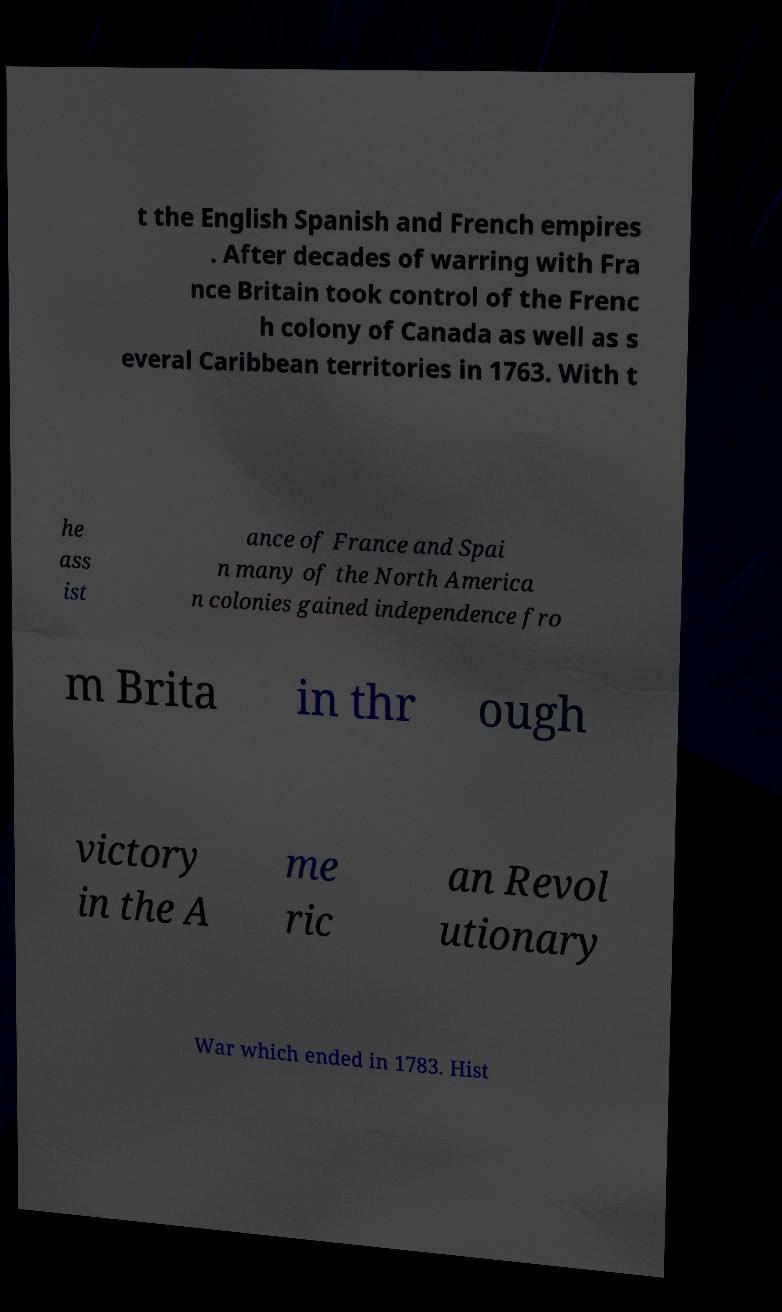For documentation purposes, I need the text within this image transcribed. Could you provide that? t the English Spanish and French empires . After decades of warring with Fra nce Britain took control of the Frenc h colony of Canada as well as s everal Caribbean territories in 1763. With t he ass ist ance of France and Spai n many of the North America n colonies gained independence fro m Brita in thr ough victory in the A me ric an Revol utionary War which ended in 1783. Hist 